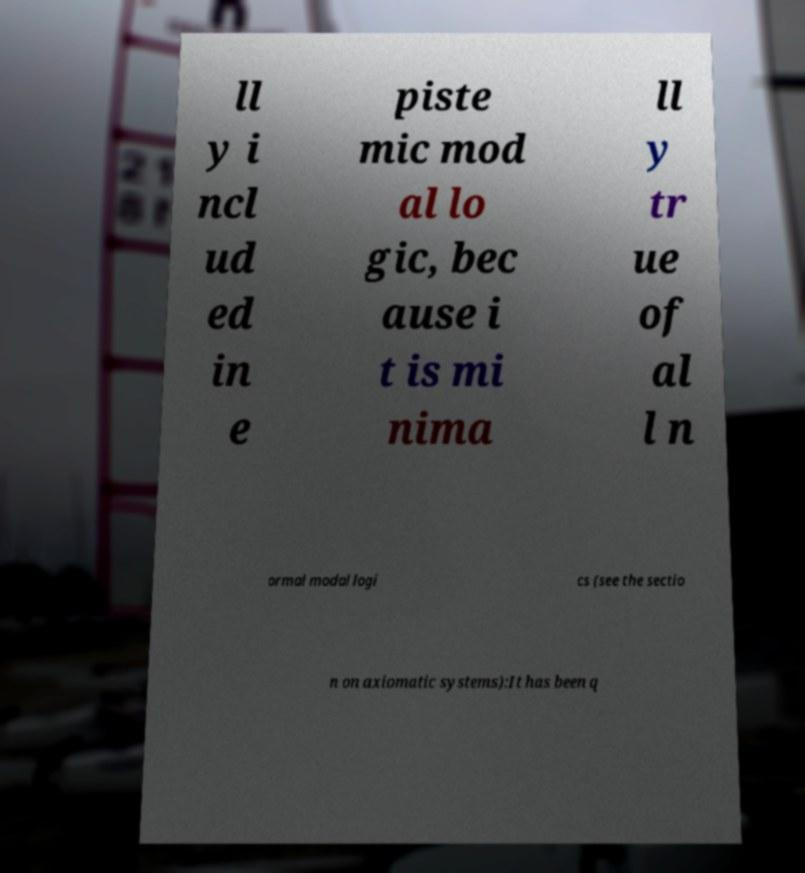What messages or text are displayed in this image? I need them in a readable, typed format. ll y i ncl ud ed in e piste mic mod al lo gic, bec ause i t is mi nima ll y tr ue of al l n ormal modal logi cs (see the sectio n on axiomatic systems):It has been q 